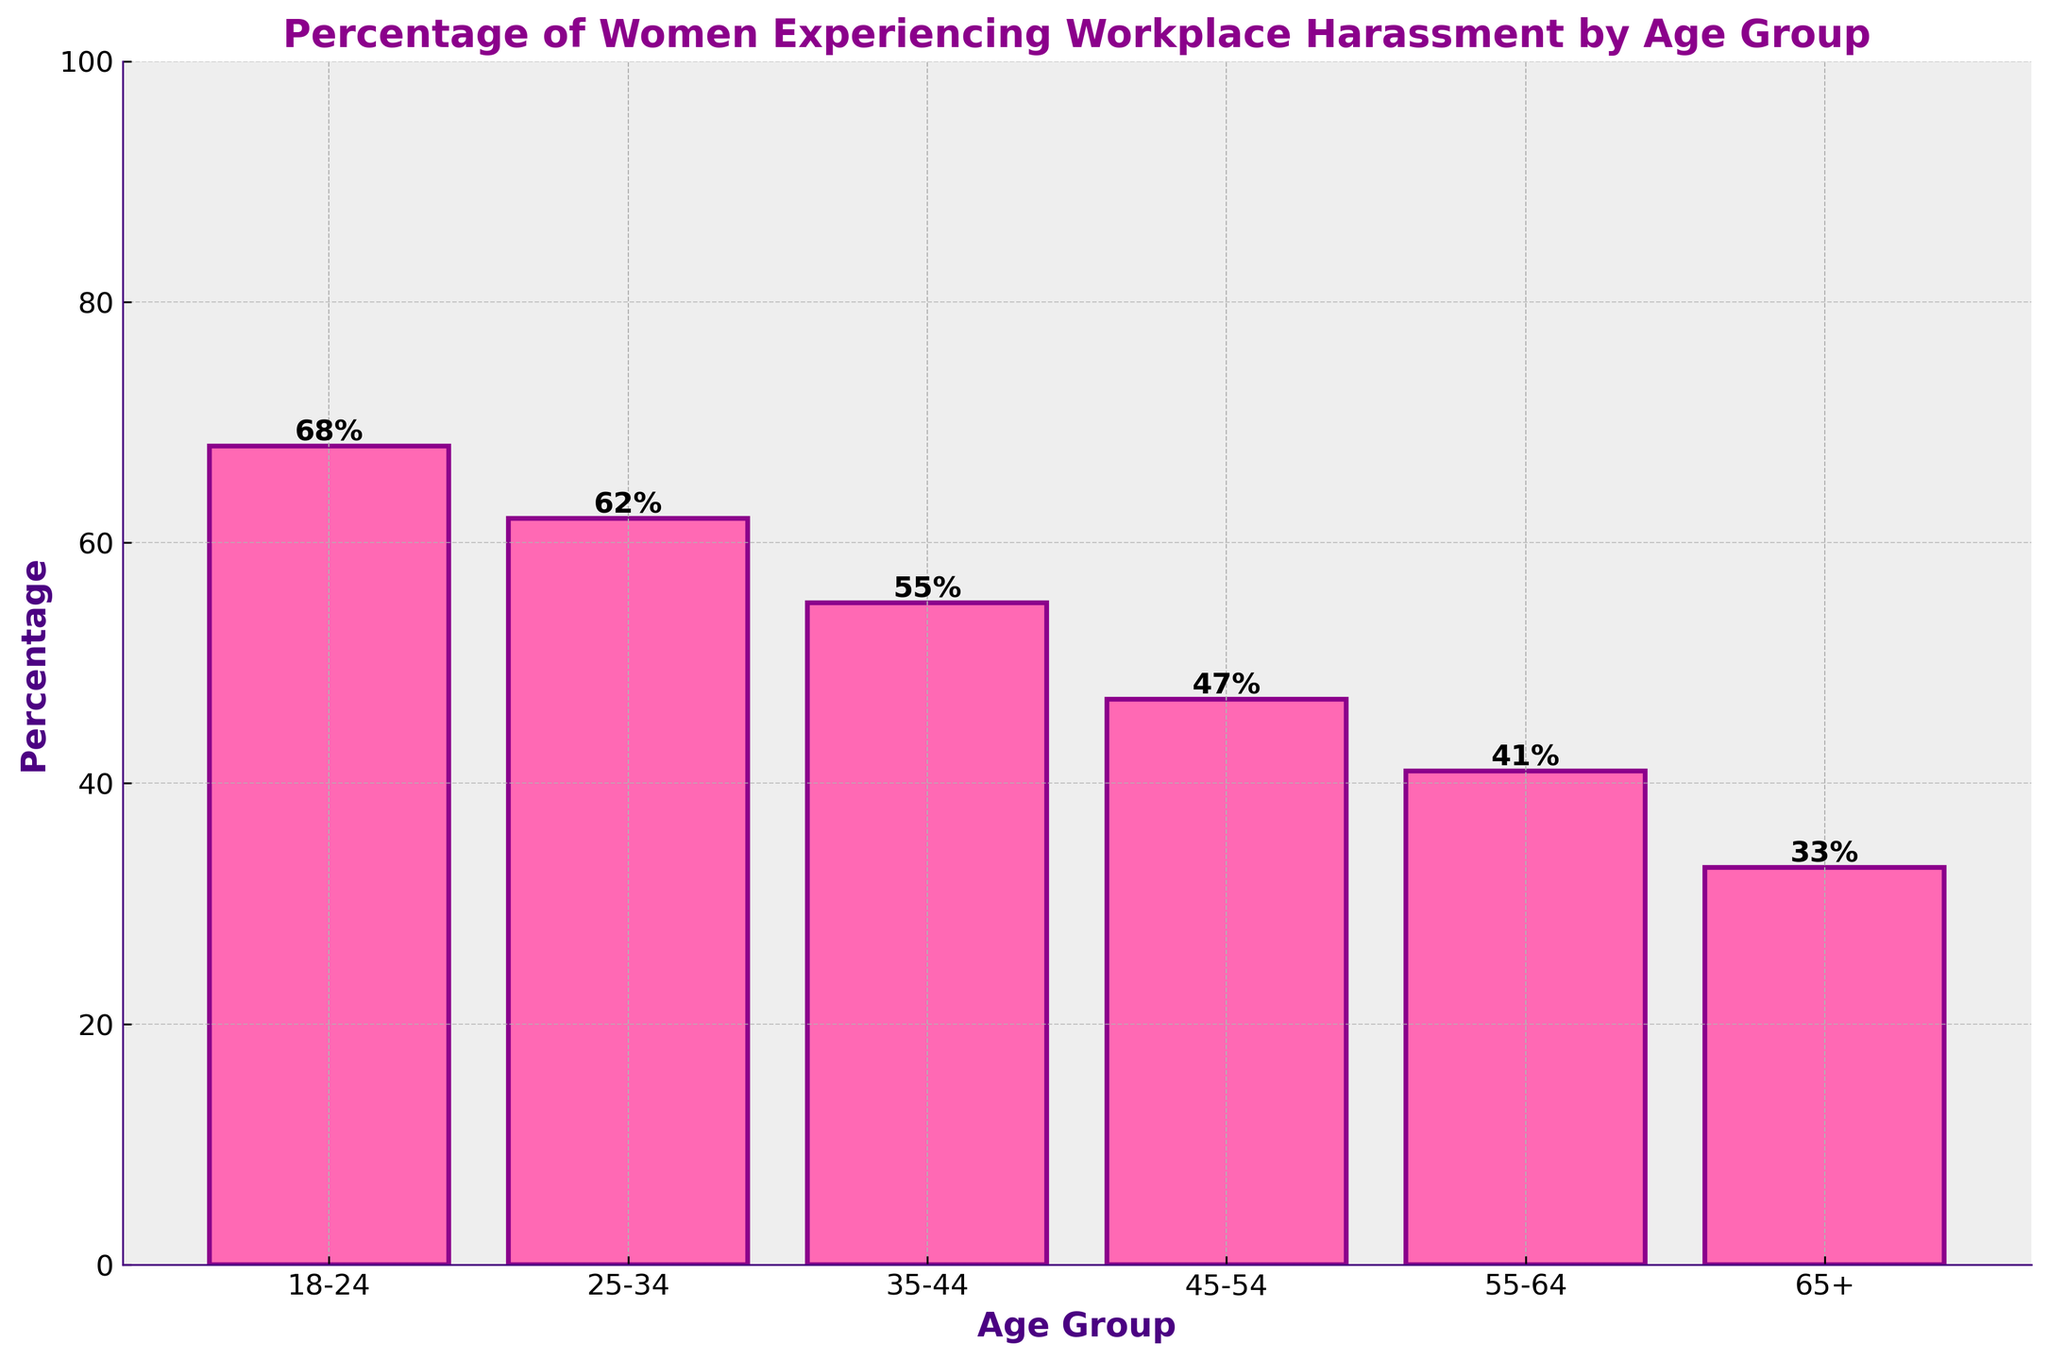What age group has the highest percentage of women experiencing workplace harassment? By examining the height of the bars, it's apparent that the 18-24 age group has the tallest bar, indicating the highest percentage.
Answer: 18-24 What is the difference in the percentage of women experiencing workplace harassment between the 18-24 and 65+ age groups? The percentage for the 18-24 age group is 68%, while for the 65+ age group, it is 33%. The difference is calculated as 68% - 33% = 35%.
Answer: 35% Which age group has the lowest percentage of women experiencing workplace harassment? The shortest bar corresponds to the 65+ age group, indicating the lowest percentage.
Answer: 65+ What is the average percentage of women experiencing workplace harassment across all age groups? The percentages for all age groups are 68%, 62%, 55%, 47%, 41%, and 33%. The sum of these values is 68 + 62 + 55 + 47 + 41 + 33 = 306. There are 6 age groups, so the average is 306 / 6 = 51%.
Answer: 51% Among the age groups 35-44 and 45-54, which one has a higher percentage of women experiencing workplace harassment, and by how much? The percentage for the 35-44 age group is 55%, and for the 45-54 age group, it is 47%. The 35-44 age group has a higher percentage by 55% - 47% = 8%.
Answer: 35-44, 8% What is the median percentage value of women experiencing workplace harassment for the age groups? The percentages are 68%, 62%, 55%, 47%, 41%, and 33%. Arranged in order, they are 33%, 41%, 47%, 55%, 62%, 68%. The median is the average of the third and fourth values: (47 + 55) / 2 = 51%.
Answer: 51% By how much does the percentage of women experiencing workplace harassment decrease from the 25-34 age group to the 55-64 age group? The percentage for the 25-34 age group is 62%, and for the 55-64 age group, it is 41%. The decrease is calculated as 62% - 41% = 21%.
Answer: 21% How many age groups have a percentage of women experiencing workplace harassment that is higher than 50%? The age groups with percentages higher than 50% are 18-24 (68%), 25-34 (62%), and 35-44 (55%). Therefore, there are three age groups.
Answer: 3 If you combine the percentages for the 45-54 and 55-64 age groups, what is the total? The percentage for the 45-54 age group is 47%, and for the 55-64 age group, it is 41%. The combined total is 47% + 41% = 88%.
Answer: 88% 